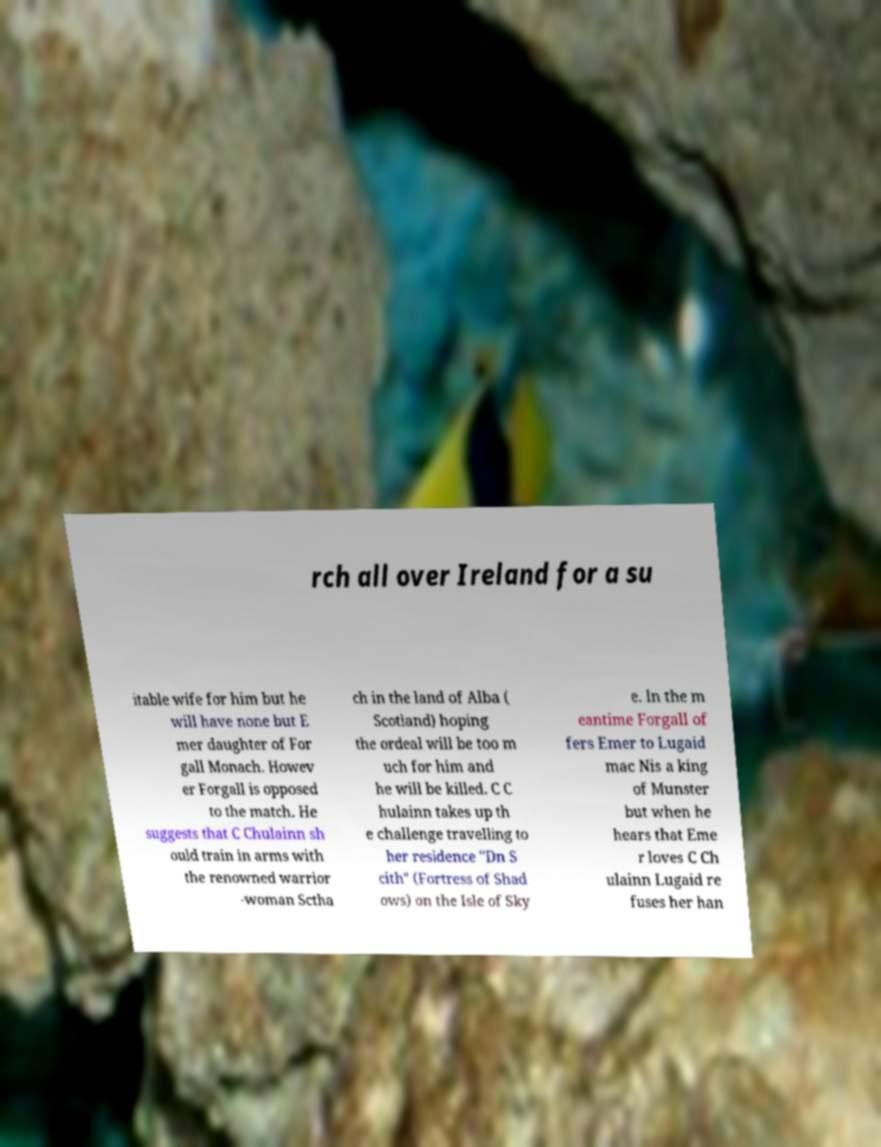Please identify and transcribe the text found in this image. rch all over Ireland for a su itable wife for him but he will have none but E mer daughter of For gall Monach. Howev er Forgall is opposed to the match. He suggests that C Chulainn sh ould train in arms with the renowned warrior -woman Sctha ch in the land of Alba ( Scotland) hoping the ordeal will be too m uch for him and he will be killed. C C hulainn takes up th e challenge travelling to her residence "Dn S cith" (Fortress of Shad ows) on the Isle of Sky e. In the m eantime Forgall of fers Emer to Lugaid mac Nis a king of Munster but when he hears that Eme r loves C Ch ulainn Lugaid re fuses her han 